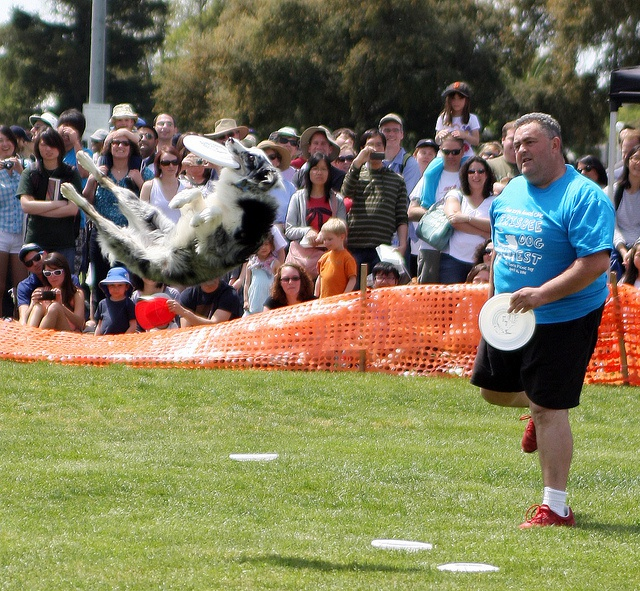Describe the objects in this image and their specific colors. I can see people in white, black, brown, blue, and lightblue tones, dog in white, black, lightgray, darkgray, and gray tones, people in white, black, gray, brown, and darkgray tones, people in white, black, gray, and maroon tones, and people in white, black, lavender, and brown tones in this image. 